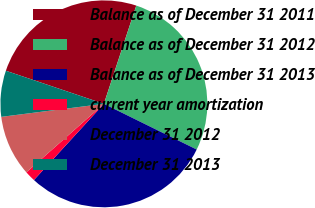<chart> <loc_0><loc_0><loc_500><loc_500><pie_chart><fcel>Balance as of December 31 2011<fcel>Balance as of December 31 2012<fcel>Balance as of December 31 2013<fcel>current year amortization<fcel>December 31 2012<fcel>December 31 2013<nl><fcel>24.89%<fcel>27.21%<fcel>29.54%<fcel>1.66%<fcel>9.51%<fcel>7.19%<nl></chart> 